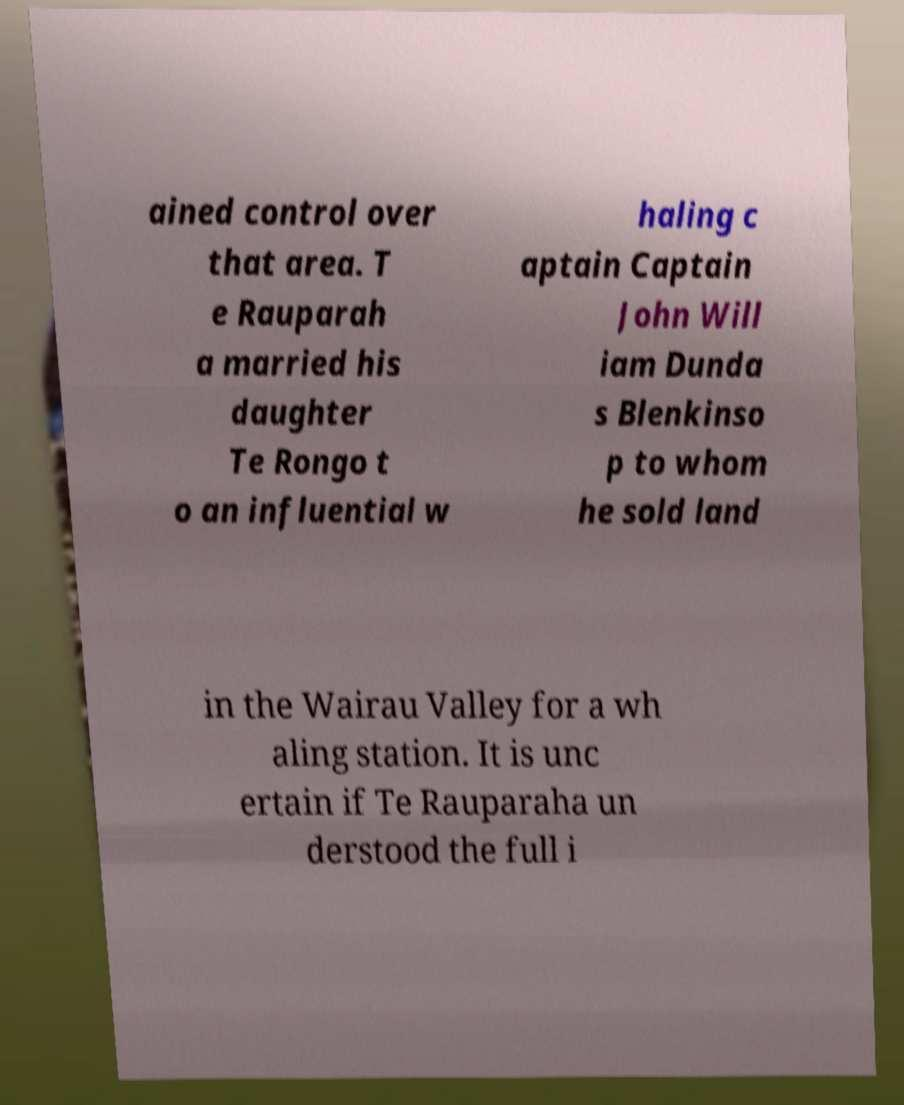Could you assist in decoding the text presented in this image and type it out clearly? ained control over that area. T e Rauparah a married his daughter Te Rongo t o an influential w haling c aptain Captain John Will iam Dunda s Blenkinso p to whom he sold land in the Wairau Valley for a wh aling station. It is unc ertain if Te Rauparaha un derstood the full i 